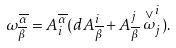<formula> <loc_0><loc_0><loc_500><loc_500>\omega _ { \overline { \beta } } ^ { \overline { \alpha } } = A _ { i } ^ { \overline { \alpha } } ( d A _ { \overline { \beta } } ^ { i } + A _ { \overline { \beta } } ^ { j } \stackrel { \vee } { \omega } _ { j } ^ { i } ) .</formula> 